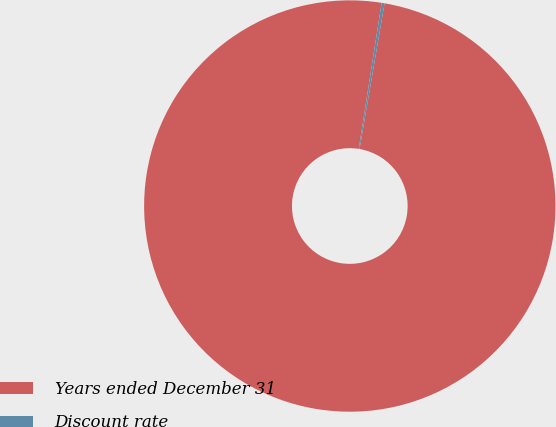Convert chart. <chart><loc_0><loc_0><loc_500><loc_500><pie_chart><fcel>Years ended December 31<fcel>Discount rate<nl><fcel>99.77%<fcel>0.23%<nl></chart> 